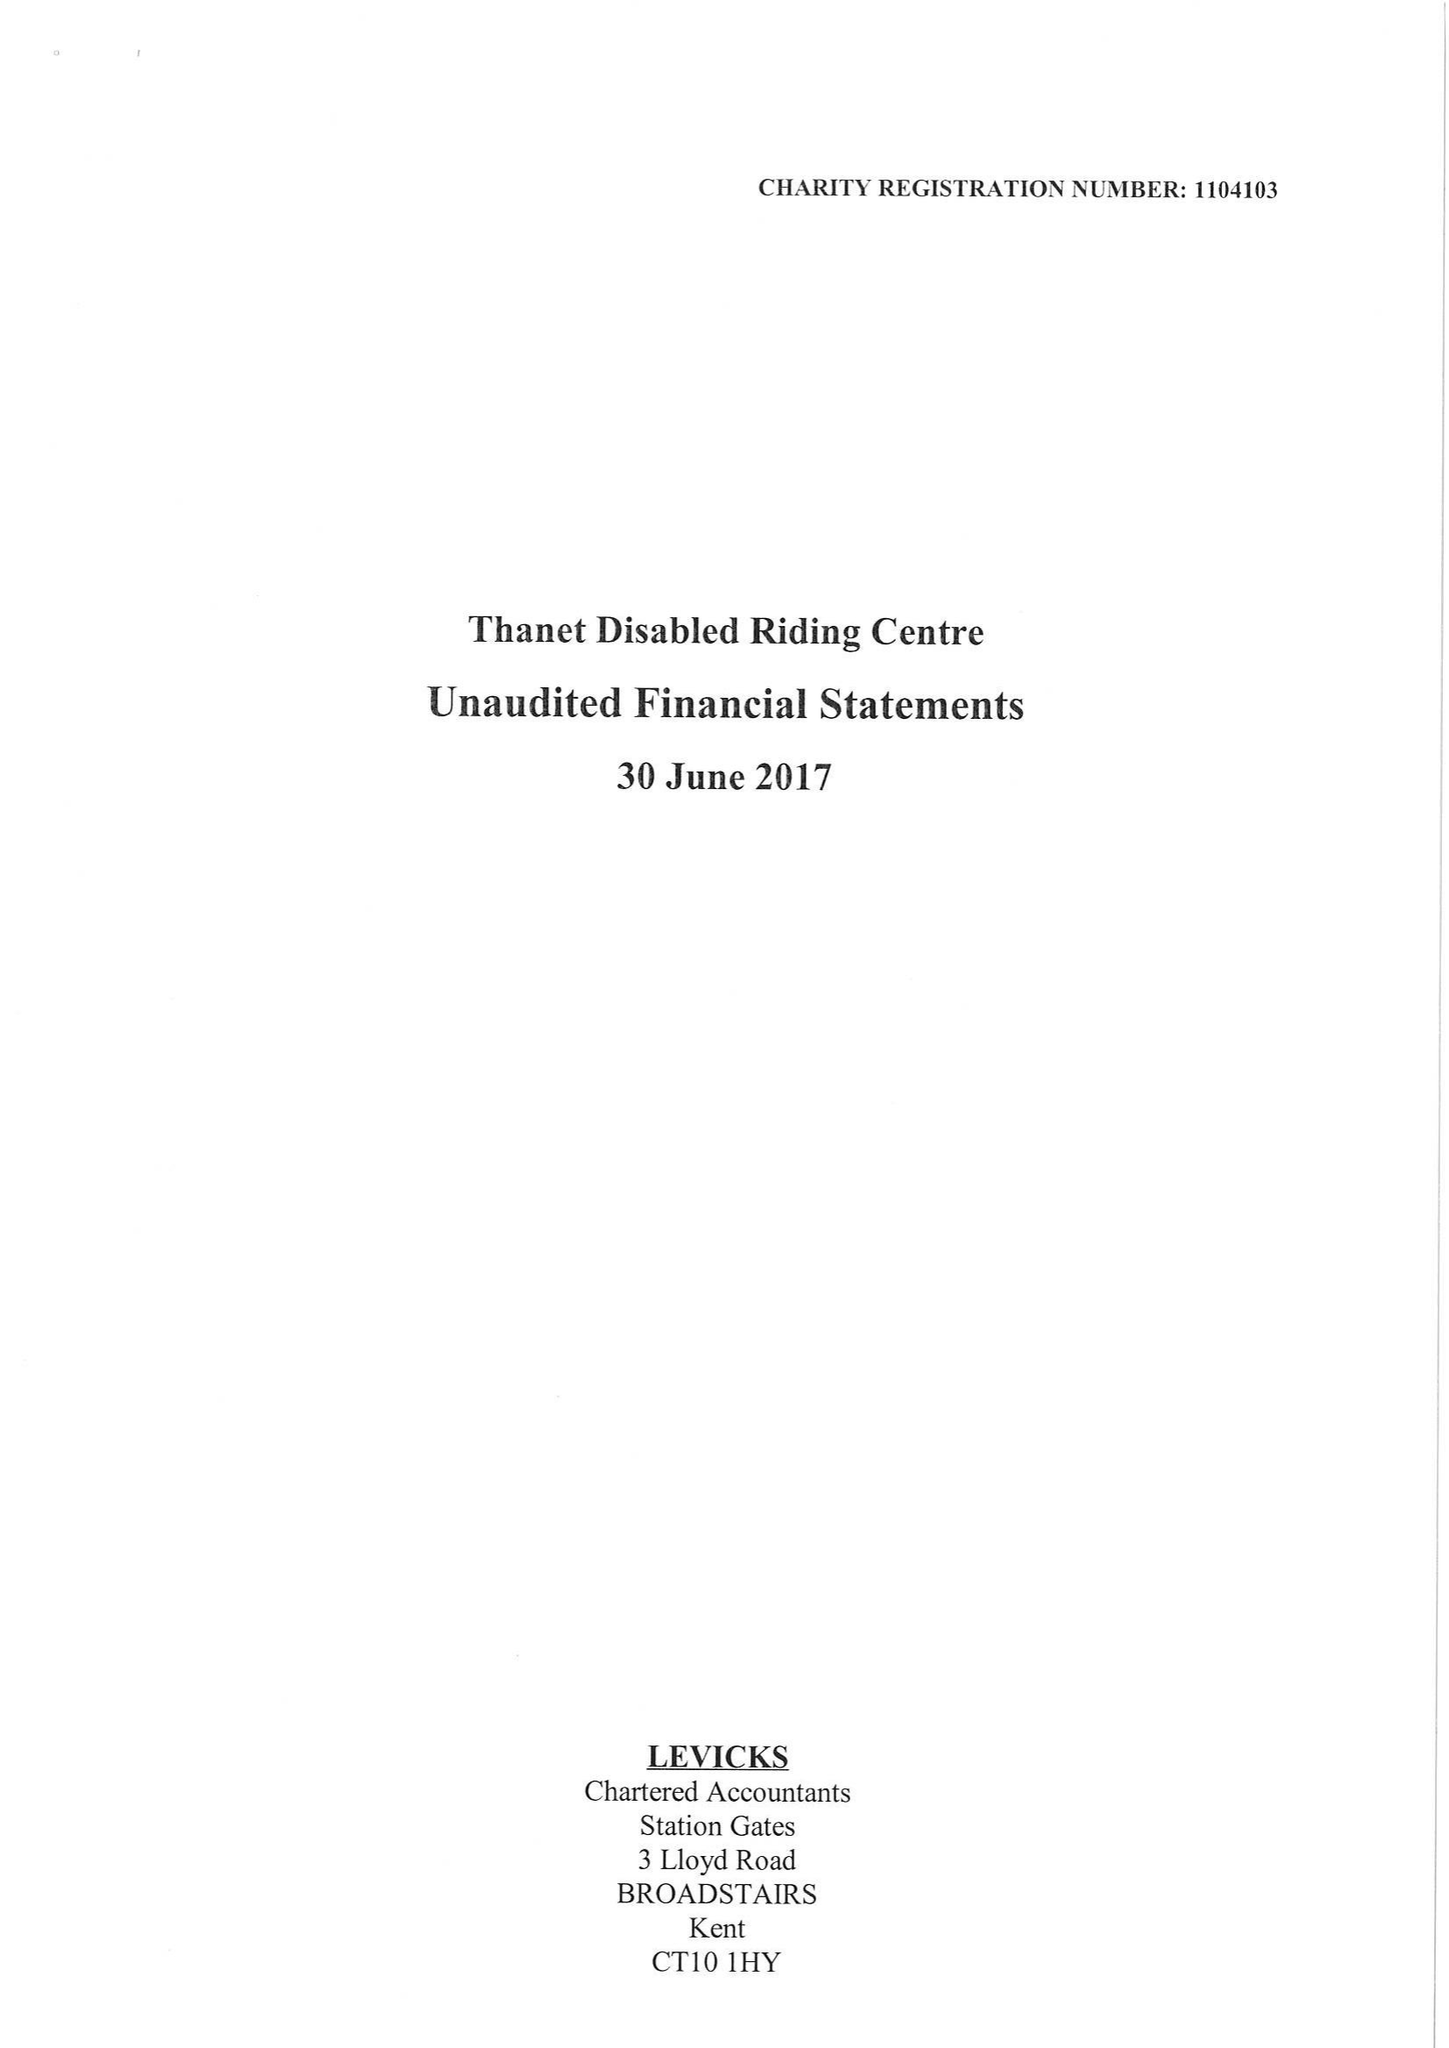What is the value for the address__post_town?
Answer the question using a single word or phrase. BROADSTAIRS 